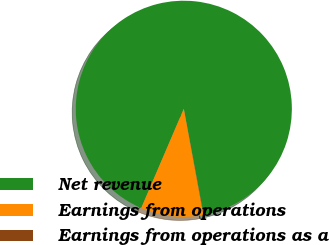Convert chart. <chart><loc_0><loc_0><loc_500><loc_500><pie_chart><fcel>Net revenue<fcel>Earnings from operations<fcel>Earnings from operations as a<nl><fcel>90.61%<fcel>9.36%<fcel>0.04%<nl></chart> 